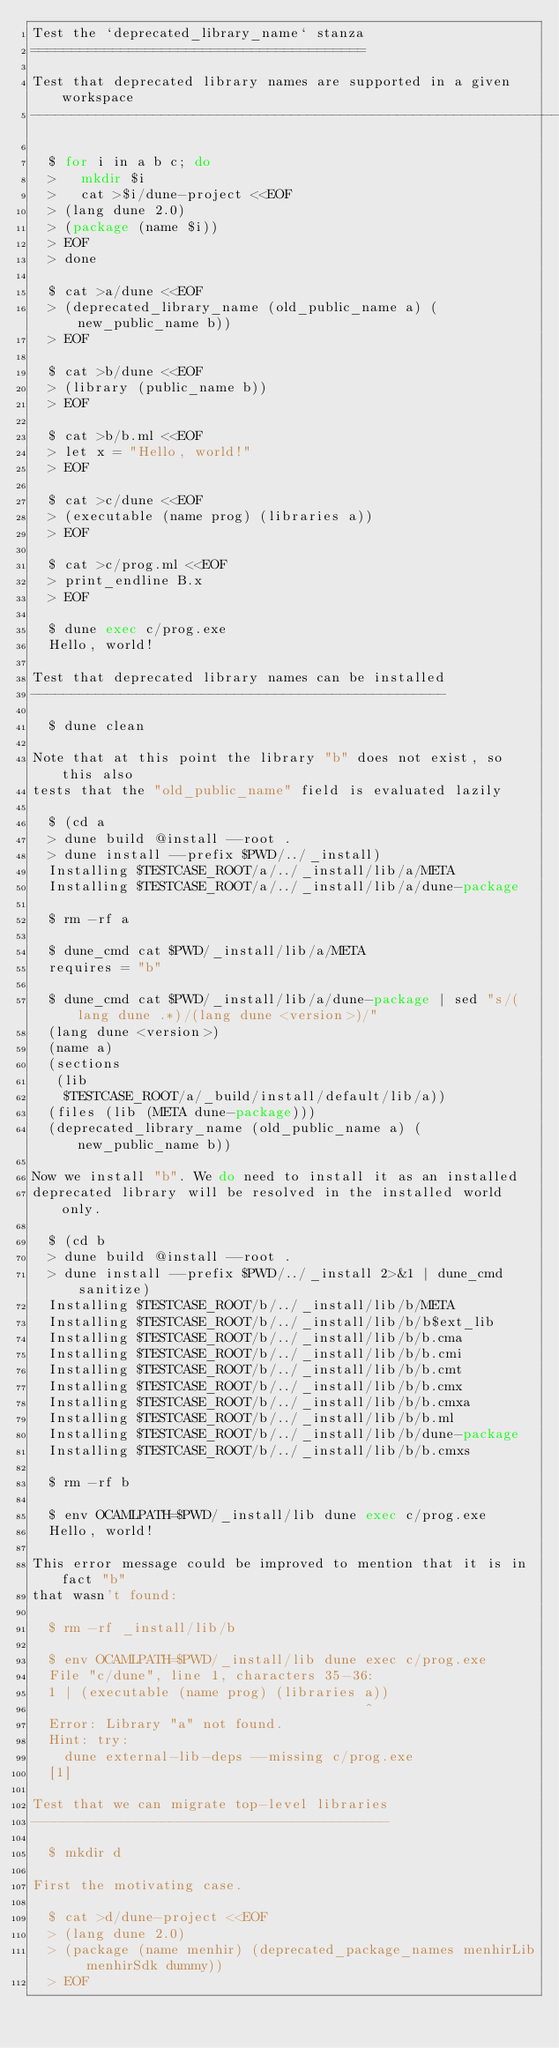Convert code to text. <code><loc_0><loc_0><loc_500><loc_500><_Perl_>Test the `deprecated_library_name` stanza
=========================================

Test that deprecated library names are supported in a given workspace
---------------------------------------------------------------------

  $ for i in a b c; do
  >   mkdir $i
  >   cat >$i/dune-project <<EOF
  > (lang dune 2.0)
  > (package (name $i))
  > EOF
  > done

  $ cat >a/dune <<EOF
  > (deprecated_library_name (old_public_name a) (new_public_name b))
  > EOF

  $ cat >b/dune <<EOF
  > (library (public_name b))
  > EOF

  $ cat >b/b.ml <<EOF
  > let x = "Hello, world!"
  > EOF

  $ cat >c/dune <<EOF
  > (executable (name prog) (libraries a))
  > EOF

  $ cat >c/prog.ml <<EOF
  > print_endline B.x
  > EOF

  $ dune exec c/prog.exe
  Hello, world!

Test that deprecated library names can be installed
---------------------------------------------------

  $ dune clean

Note that at this point the library "b" does not exist, so this also
tests that the "old_public_name" field is evaluated lazily

  $ (cd a
  > dune build @install --root .
  > dune install --prefix $PWD/../_install)
  Installing $TESTCASE_ROOT/a/../_install/lib/a/META
  Installing $TESTCASE_ROOT/a/../_install/lib/a/dune-package

  $ rm -rf a

  $ dune_cmd cat $PWD/_install/lib/a/META
  requires = "b"

  $ dune_cmd cat $PWD/_install/lib/a/dune-package | sed "s/(lang dune .*)/(lang dune <version>)/"
  (lang dune <version>)
  (name a)
  (sections
   (lib
    $TESTCASE_ROOT/a/_build/install/default/lib/a))
  (files (lib (META dune-package)))
  (deprecated_library_name (old_public_name a) (new_public_name b))

Now we install "b". We do need to install it as an installed
deprecated library will be resolved in the installed world only.

  $ (cd b
  > dune build @install --root .
  > dune install --prefix $PWD/../_install 2>&1 | dune_cmd sanitize)
  Installing $TESTCASE_ROOT/b/../_install/lib/b/META
  Installing $TESTCASE_ROOT/b/../_install/lib/b/b$ext_lib
  Installing $TESTCASE_ROOT/b/../_install/lib/b/b.cma
  Installing $TESTCASE_ROOT/b/../_install/lib/b/b.cmi
  Installing $TESTCASE_ROOT/b/../_install/lib/b/b.cmt
  Installing $TESTCASE_ROOT/b/../_install/lib/b/b.cmx
  Installing $TESTCASE_ROOT/b/../_install/lib/b/b.cmxa
  Installing $TESTCASE_ROOT/b/../_install/lib/b/b.ml
  Installing $TESTCASE_ROOT/b/../_install/lib/b/dune-package
  Installing $TESTCASE_ROOT/b/../_install/lib/b/b.cmxs

  $ rm -rf b

  $ env OCAMLPATH=$PWD/_install/lib dune exec c/prog.exe
  Hello, world!

This error message could be improved to mention that it is in fact "b"
that wasn't found:

  $ rm -rf _install/lib/b

  $ env OCAMLPATH=$PWD/_install/lib dune exec c/prog.exe
  File "c/dune", line 1, characters 35-36:
  1 | (executable (name prog) (libraries a))
                                         ^
  Error: Library "a" not found.
  Hint: try:
    dune external-lib-deps --missing c/prog.exe
  [1]

Test that we can migrate top-level libraries
--------------------------------------------

  $ mkdir d

First the motivating case.

  $ cat >d/dune-project <<EOF
  > (lang dune 2.0)
  > (package (name menhir) (deprecated_package_names menhirLib menhirSdk dummy))
  > EOF
</code> 